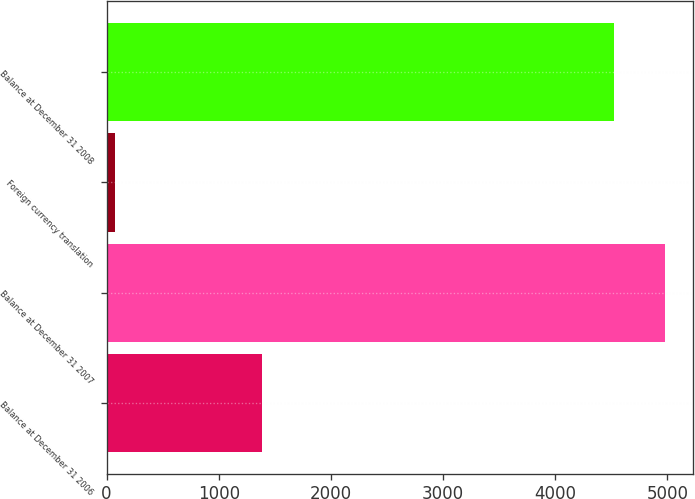Convert chart to OTSL. <chart><loc_0><loc_0><loc_500><loc_500><bar_chart><fcel>Balance at December 31 2006<fcel>Balance at December 31 2007<fcel>Foreign currency translation<fcel>Balance at December 31 2008<nl><fcel>1384<fcel>4976.6<fcel>71<fcel>4527<nl></chart> 